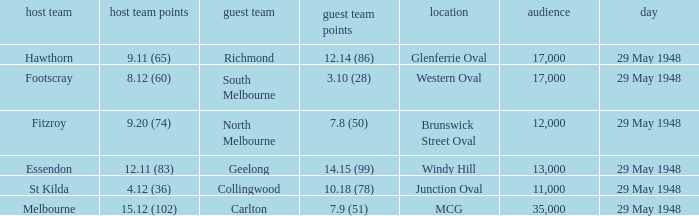In the match where north melbourne was the away team, how much did the home team score? 9.20 (74). 